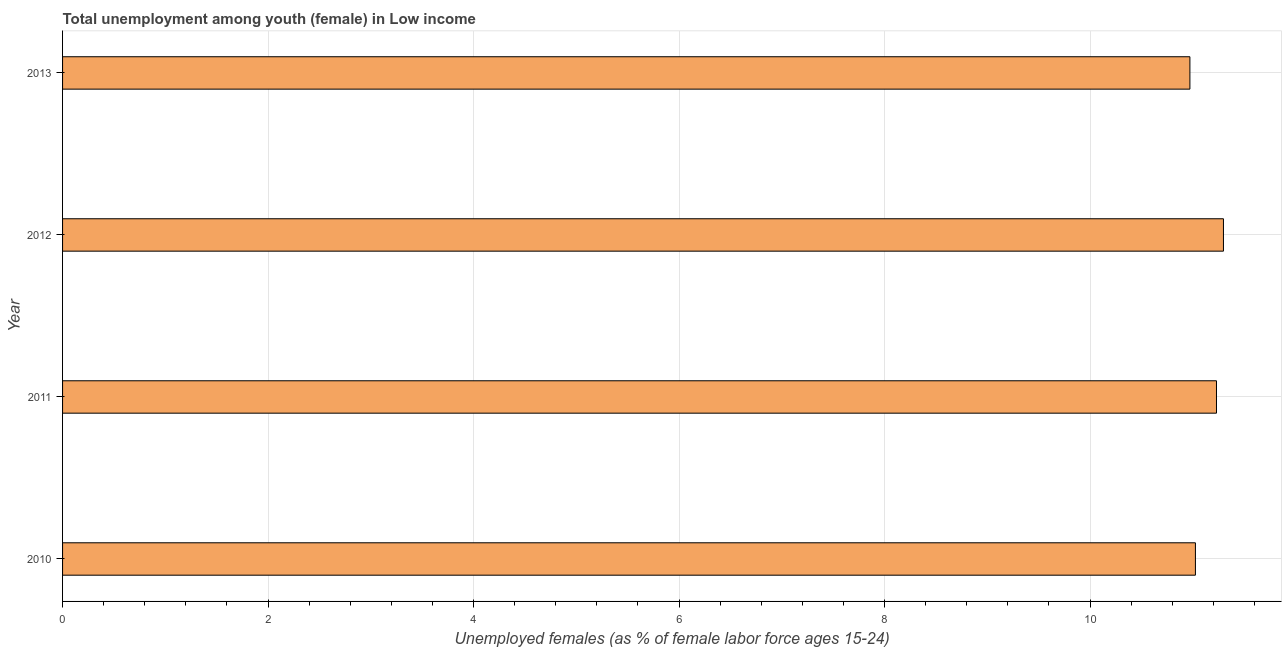Does the graph contain grids?
Give a very brief answer. Yes. What is the title of the graph?
Provide a succinct answer. Total unemployment among youth (female) in Low income. What is the label or title of the X-axis?
Provide a short and direct response. Unemployed females (as % of female labor force ages 15-24). What is the unemployed female youth population in 2010?
Offer a terse response. 11.03. Across all years, what is the maximum unemployed female youth population?
Provide a succinct answer. 11.3. Across all years, what is the minimum unemployed female youth population?
Make the answer very short. 10.97. In which year was the unemployed female youth population maximum?
Your answer should be compact. 2012. What is the sum of the unemployed female youth population?
Keep it short and to the point. 44.53. What is the difference between the unemployed female youth population in 2010 and 2011?
Your answer should be very brief. -0.2. What is the average unemployed female youth population per year?
Ensure brevity in your answer.  11.13. What is the median unemployed female youth population?
Ensure brevity in your answer.  11.13. Do a majority of the years between 2010 and 2013 (inclusive) have unemployed female youth population greater than 8 %?
Provide a short and direct response. Yes. What is the difference between the highest and the second highest unemployed female youth population?
Your answer should be very brief. 0.07. What is the difference between the highest and the lowest unemployed female youth population?
Give a very brief answer. 0.33. How many bars are there?
Your answer should be very brief. 4. How many years are there in the graph?
Your response must be concise. 4. What is the difference between two consecutive major ticks on the X-axis?
Provide a short and direct response. 2. Are the values on the major ticks of X-axis written in scientific E-notation?
Keep it short and to the point. No. What is the Unemployed females (as % of female labor force ages 15-24) of 2010?
Provide a short and direct response. 11.03. What is the Unemployed females (as % of female labor force ages 15-24) of 2011?
Your answer should be very brief. 11.23. What is the Unemployed females (as % of female labor force ages 15-24) of 2012?
Provide a succinct answer. 11.3. What is the Unemployed females (as % of female labor force ages 15-24) of 2013?
Offer a very short reply. 10.97. What is the difference between the Unemployed females (as % of female labor force ages 15-24) in 2010 and 2011?
Offer a terse response. -0.21. What is the difference between the Unemployed females (as % of female labor force ages 15-24) in 2010 and 2012?
Your answer should be compact. -0.27. What is the difference between the Unemployed females (as % of female labor force ages 15-24) in 2010 and 2013?
Offer a terse response. 0.05. What is the difference between the Unemployed females (as % of female labor force ages 15-24) in 2011 and 2012?
Give a very brief answer. -0.07. What is the difference between the Unemployed females (as % of female labor force ages 15-24) in 2011 and 2013?
Ensure brevity in your answer.  0.26. What is the difference between the Unemployed females (as % of female labor force ages 15-24) in 2012 and 2013?
Your answer should be very brief. 0.33. What is the ratio of the Unemployed females (as % of female labor force ages 15-24) in 2010 to that in 2011?
Keep it short and to the point. 0.98. What is the ratio of the Unemployed females (as % of female labor force ages 15-24) in 2010 to that in 2012?
Provide a succinct answer. 0.98. What is the ratio of the Unemployed females (as % of female labor force ages 15-24) in 2011 to that in 2013?
Your answer should be very brief. 1.02. What is the ratio of the Unemployed females (as % of female labor force ages 15-24) in 2012 to that in 2013?
Give a very brief answer. 1.03. 